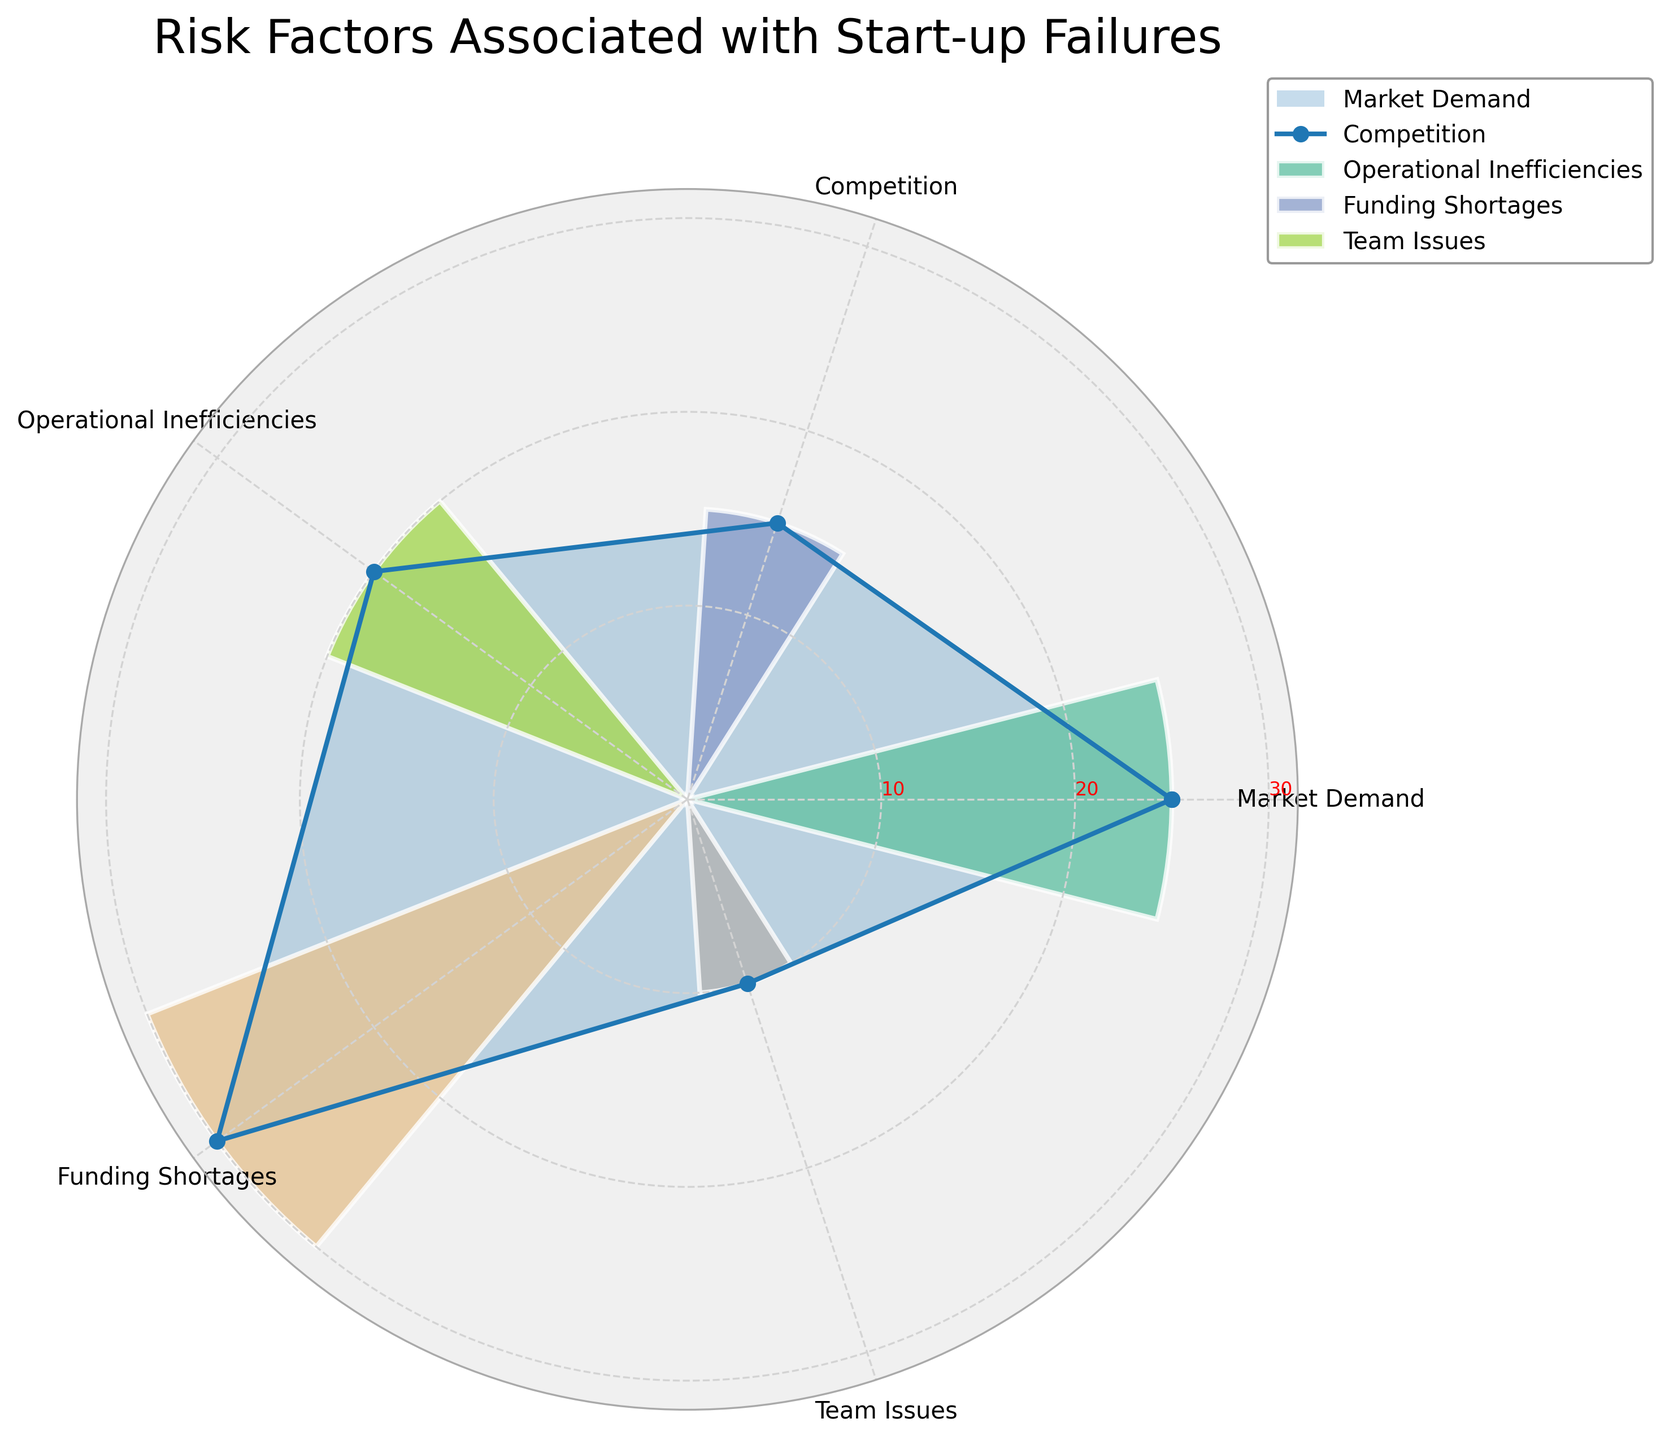What's the title of the figure? The title is shown at the top of the figure in larger font size. It provides a description of the chart's content.
Answer: Risk Factors Associated with Start-up Failures Which risk factor has the highest value in the chart? By looking at the length of the bars or the distance from the center, you can see which category extends the furthest.
Answer: Funding Shortages How many risk factors are displayed in the chart? Count the number of distinct categories labeled around the outer edge of the polar plot.
Answer: 5 What is the exact value for Operational Inefficiencies? The label for Operational Inefficiencies corresponds to a specific radial value, verified by the label and tick marks.
Answer: 20 Which risk factor has the lowest value, and what is that value? By identifying the shortest bar or the innermost point among the categories, and then referring to its label.
Answer: Team Issues, 10 What is the average value of all risk factors? Add the values of all risk factors and divide by the number of categories: (25 + 15 + 20 + 30 + 10)/5.
Answer: 20 Which two risk factors have values that sum up to 50? Identify pairs of risk factors whose values add up to 50: Funding Shortages (30) and Market Demand (20) match this criterion.
Answer: Funding Shortages and Operational Inefficiencies How does the value for Market Demand compare to Competition? Compare the radial distances or bar lengths for these two categories.
Answer: Market Demand is higher Are there any risk factors with the same value? Check if any two or more categories have bars/radial points that reach the same value on the tick marks.
Answer: No What are the radial tick mark values displayed on the chart? Observe the labeled radial lines indicating specific values used for reference in the plot.
Answer: 10, 20, 30 